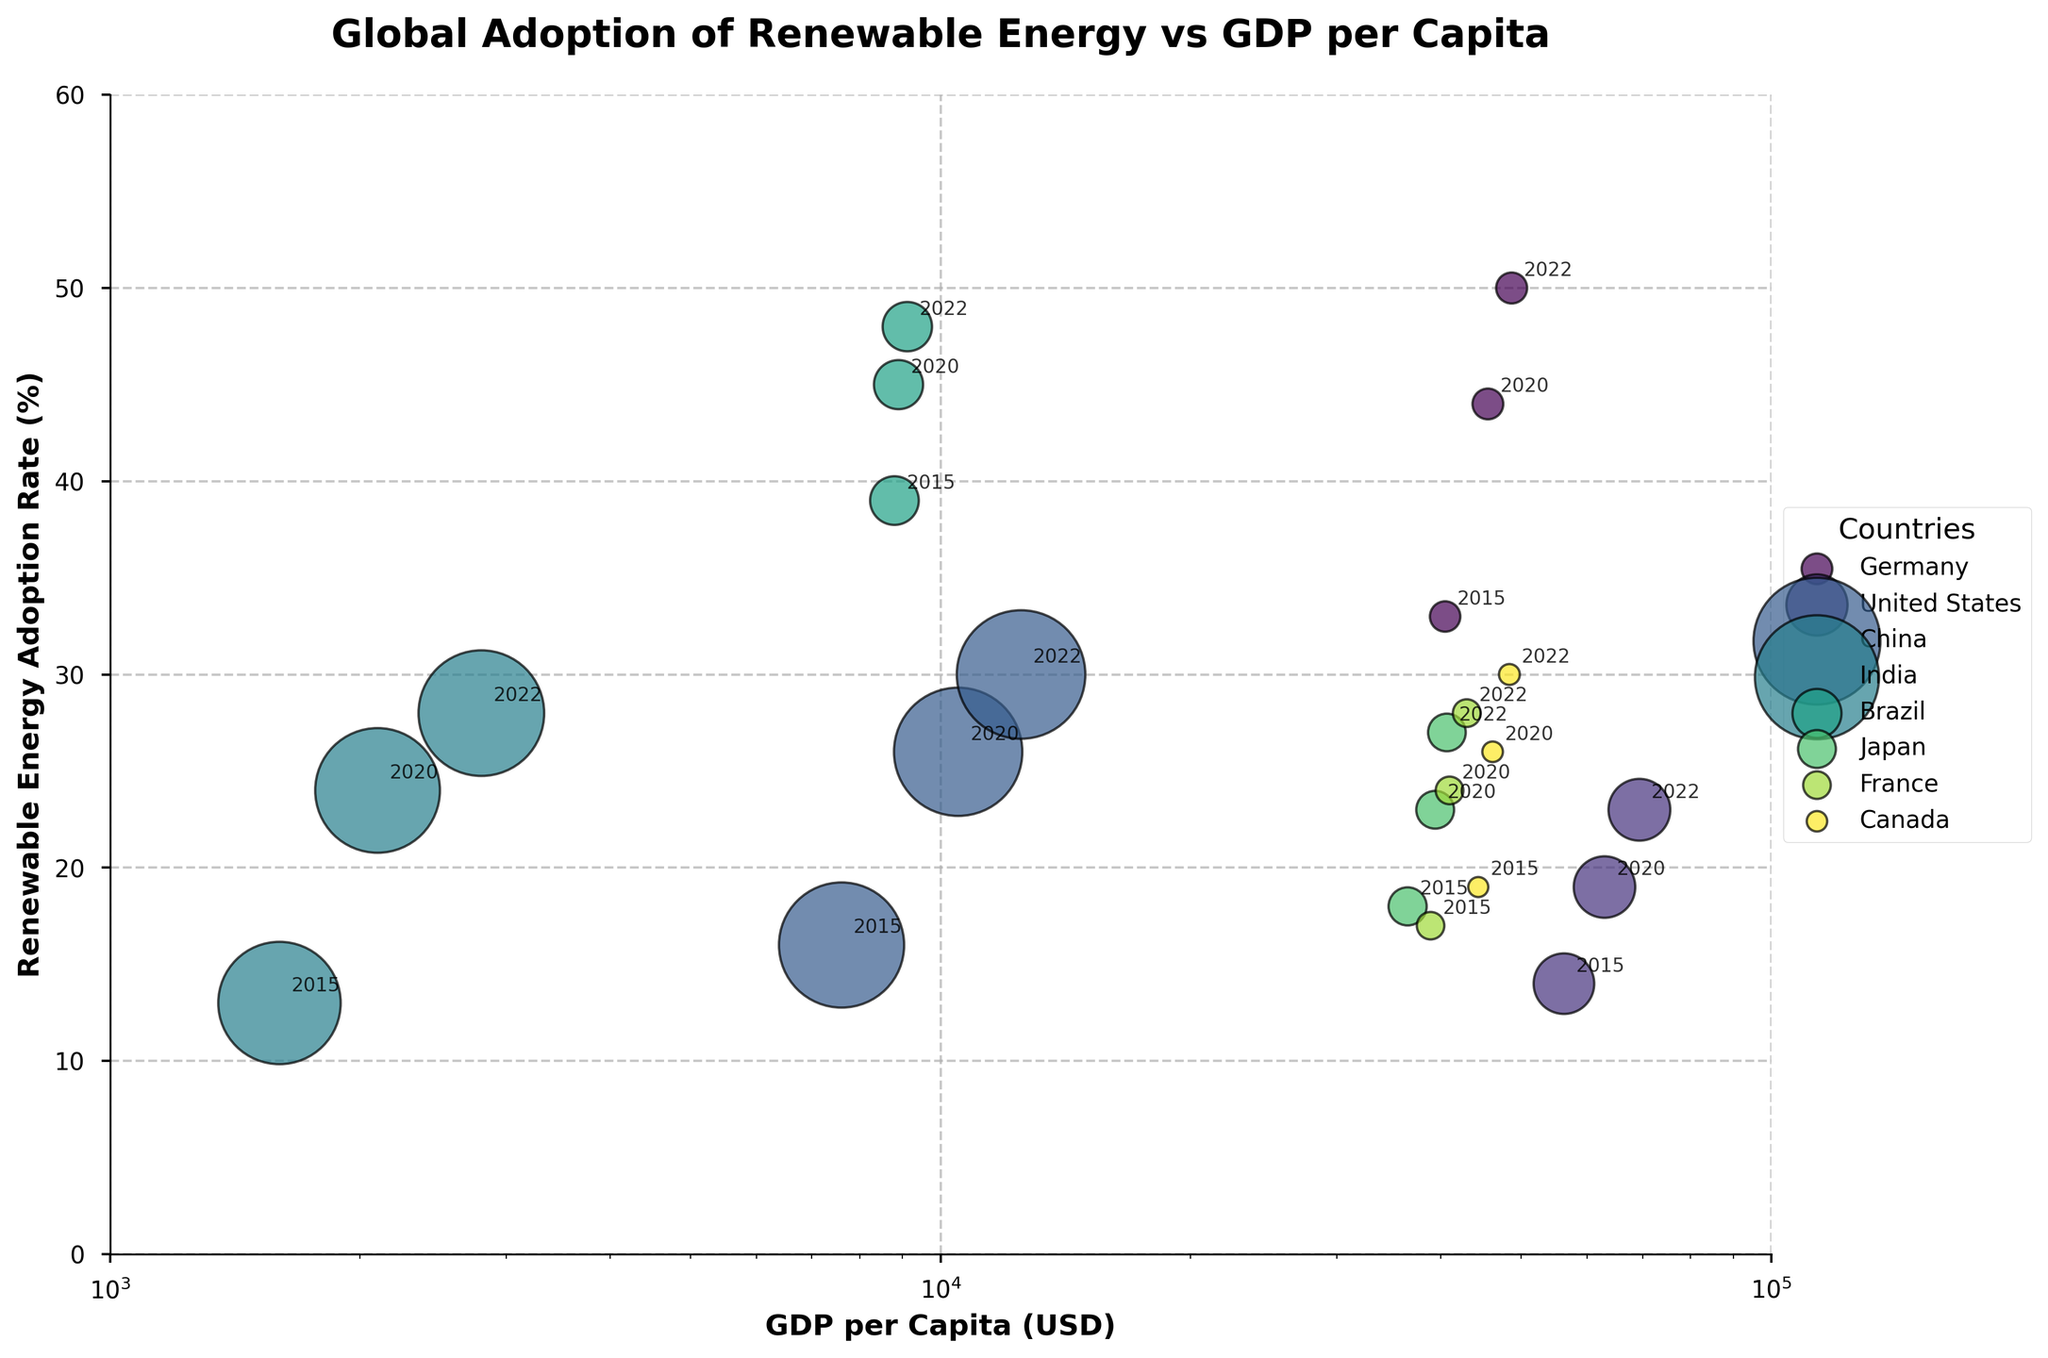What is the title of the bubble chart? The title of the chart is displayed at the top and reads: "Global Adoption of Renewable Energy vs GDP per Capita"
Answer: Global Adoption of Renewable Energy vs GDP per Capita Which country has the highest renewable energy adoption rate in 2022? By looking at the data points of 2022, the highest renewable energy adoption rate is represented by the highest y-coordinate among the 2022 data points. Brazil has the highest renewable energy adoption rate in 2022 at 48%.
Answer: Brazil How does the GDP per capita of China in 2022 compare to India in 2022? Locate the data points for China and India in 2022 on the x-axis. China's GDP per capita in 2022 is 12500 USD, whereas India's GDP per capita in 2022 is 2800 USD, hence China has a higher GDP per capita.
Answer: China has a higher GDP per capita What trend is noticeable in Germany's renewable energy adoption rate from 2015 to 2022? Track the data points for Germany along the y-axis from 2015 to 2022. The values go from 33% in 2015 to 50% in 2022, showing a consistent upward trend in renewable energy adoption.
Answer: Increasing trend Which countries show a consistent increase in renewable energy adoption rates over the years? Observe the trajectories of data points for each country along the y-axis over the years 2015, 2020, and 2022. Countries that show an increasing renewable energy adoption rate are Germany, United States, China, India, Brazil, Japan, France, and Canada.
Answer: Germany, United States, China, India, Brazil, Japan, France, and Canada Compare the population sizes of the United States and Germany in 2020 based on the bubble sizes. The bubble size represents population, and the larger the bubble, the greater the population. In 2020, the United States has a much larger bubble size compared to Germany, indicating a larger population size (331 million vs 83 million).
Answer: United States has a larger population What are the x and y-axis labels on the bubble chart? The labels are provided along the x-axis and y-axis of the chart. The x-axis label is "GDP per Capita (USD)" and the y-axis label is "Renewable Energy Adoption Rate (%)".
Answer: GDP per Capita (USD) and Renewable Energy Adoption Rate (%) Which country’s adoption rate of renewable energy shows the least change from 2015 to 2022? Compare the differences in y-values from 2015 to 2022 for each country. France shows the least change, moving from 17% to 28%, a difference of 11 percentage points.
Answer: France What is the relationship between GDP per capita and renewable energy adoption rates for most countries? Notice the position of countries on the chart. Generally, countries with higher GDP per capita tend to have higher renewable energy adoption rates, indicating a positive correlation.
Answer: Positive correlation 